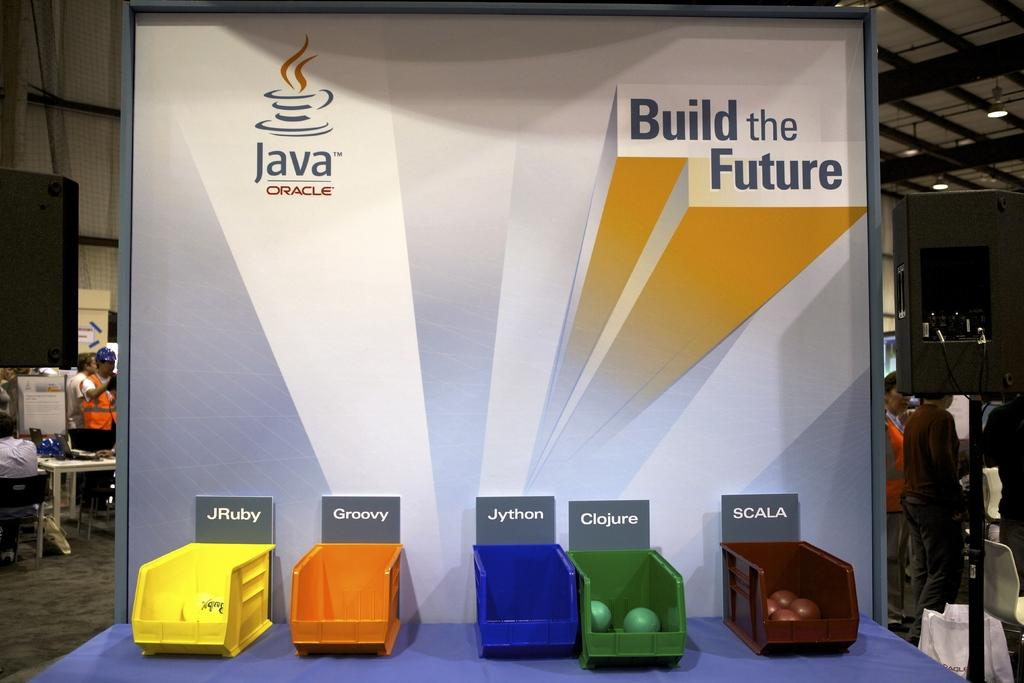<image>
Describe the image concisely. A Build the Future display with colorful baskets. 